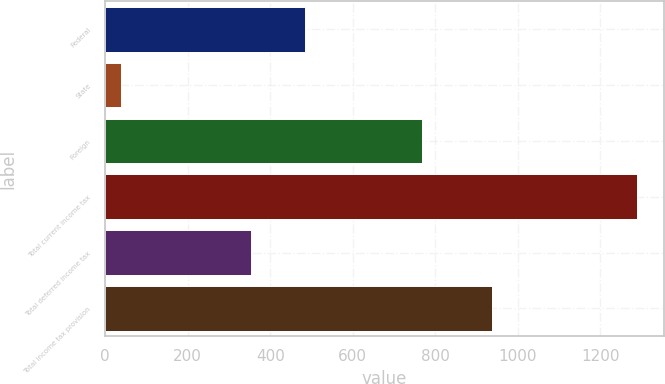<chart> <loc_0><loc_0><loc_500><loc_500><bar_chart><fcel>Federal<fcel>State<fcel>Foreign<fcel>Total current income tax<fcel>Total deferred income tax<fcel>Total income tax provision<nl><fcel>484<fcel>37<fcel>768<fcel>1289<fcel>352<fcel>937<nl></chart> 